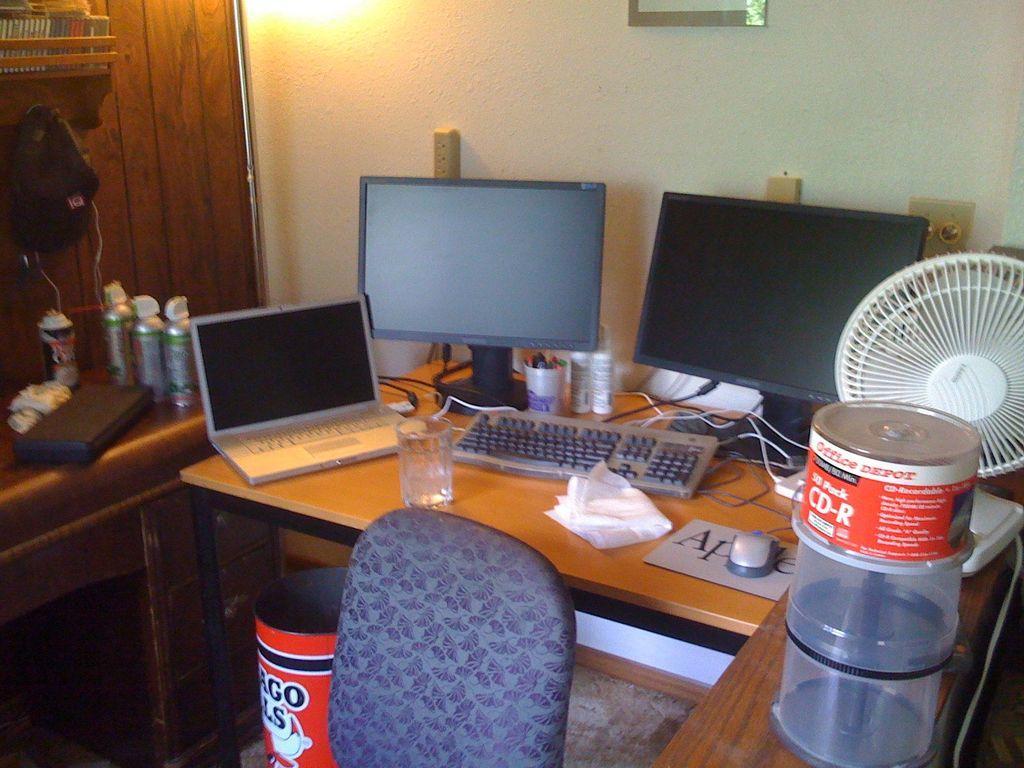Describe this image in one or two sentences. In the center we can see the table on the table we can see monitors and keyboard etc. In the front bottom there is a chair,coming to the left corner we can see another table. On the table they were some objects. And coming to the right side we can see table fan. Coming to the background we can see the wall. 